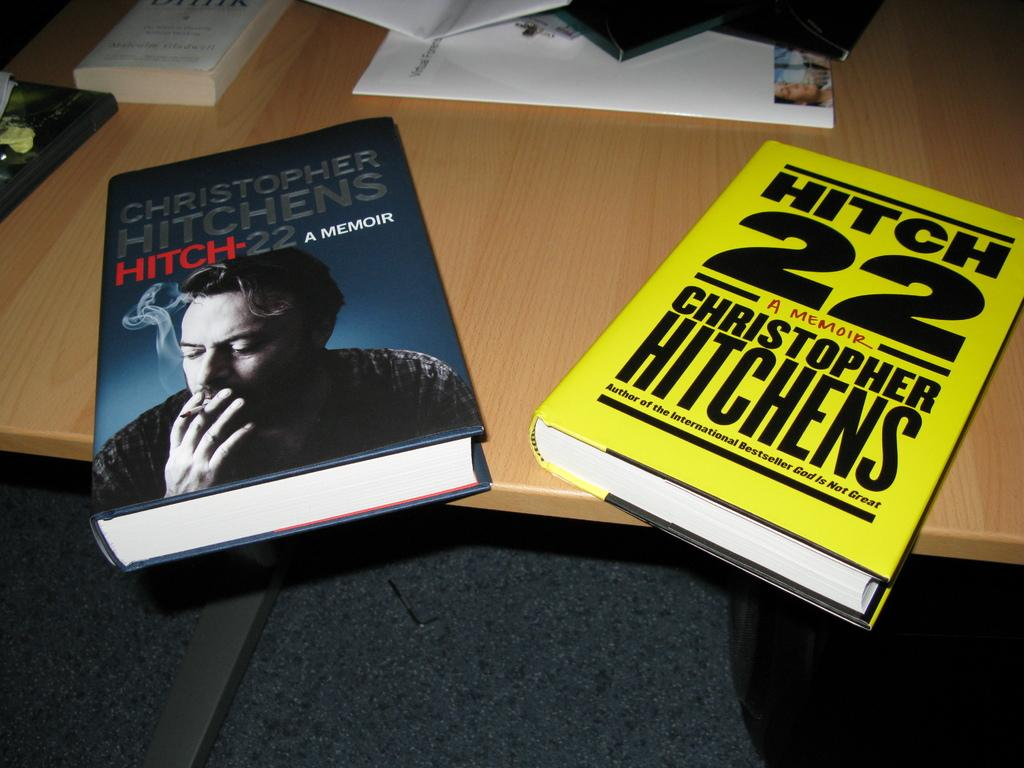<image>
Write a terse but informative summary of the picture. Two copies of the book Hitch 22 by Christopher Hitchens on a table 